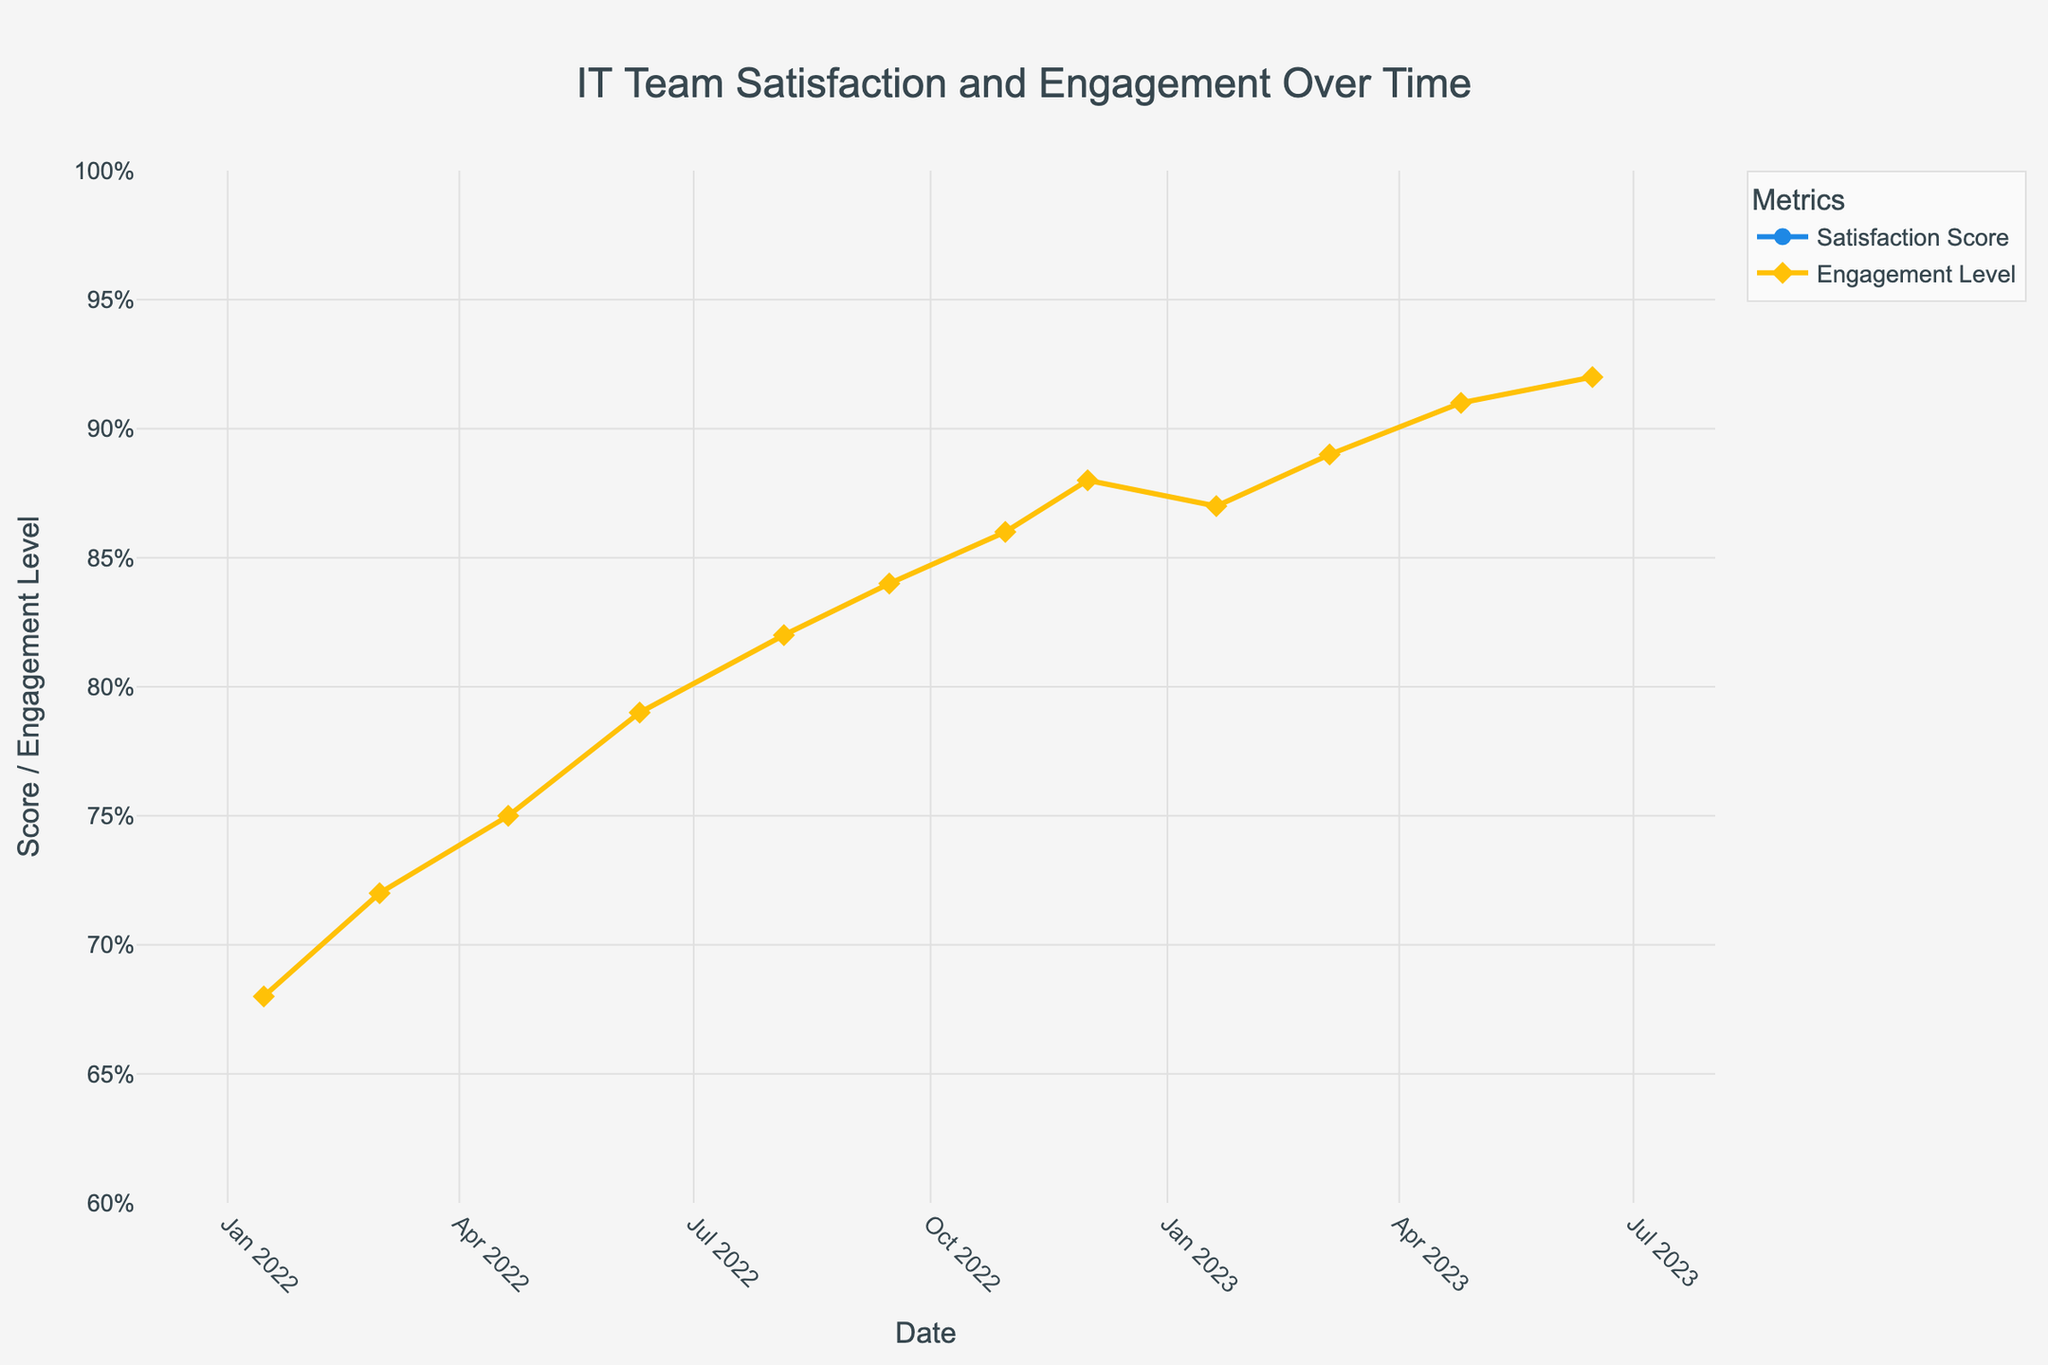What's the overall trend in satisfaction scores from January 2022 to June 2023? The satisfaction scores show a consistent upward trend from 7.2 in January 2022 to 9.3 in June 2023. Each leadership initiative seems to correspond to an increase in scores.
Answer: Upward trend How did the team engagement level change between the New Year Team Building Event and the Cross-functional Project Initiative? The team engagement level increased from 68% in January 2022 during the New Year Team Building Event to 89% in March 2023 during the Cross-functional Project Initiative.
Answer: Increased What is the difference in satisfaction scores between the Mentorship Program Launch and the Employee-led Tech Talks? The satisfaction score for the Mentorship Program Launch was 8.1, and for the Employee-led Tech Talks, it was 9.2. The difference is 9.2 - 8.1 = 1.1.
Answer: 1.1 Which leadership initiative saw the highest engagement level? The Wellness Program Integration in June 2023 saw the highest engagement level at 92%.
Answer: Wellness Program Integration Compare the satisfaction scores between the Hackathon Competition and the AI and Machine Learning Workshop. Which had a higher score? The satisfaction score for the Hackathon Competition was 7.8, while the AI and Machine Learning Workshop had a score of 8.8. The AI and Machine Learning Workshop had a higher score.
Answer: AI and Machine Learning Workshop What’s the percentage increase in engagement level from the New Year Team Building Event to the Year-End Recognition Ceremony? Engagement level increased from 68% to 88%. The percentage increase is ((88 - 68) / 68) * 100 = 29.4%.
Answer: 29.4% What was the average satisfaction score over the entire period? The satisfaction scores are: 7.2, 7.5, 7.8, 8.1, 8.3, 8.5, 8.7, 8.9, 8.8, 9.0, 9.2, 9.3. The sum is 101.3, and the average is 101.3 / 12 ≈ 8.44.
Answer: 8.44 Describe the visual difference between satisfaction scores and engagement levels on the chart. Satisfaction scores are marked with circles and blue lines, while engagement levels use diamond markers and yellow lines. Both metrics increase over time but have distinct visual attributes making them easily distinguishable.
Answer: Different colors and markers 